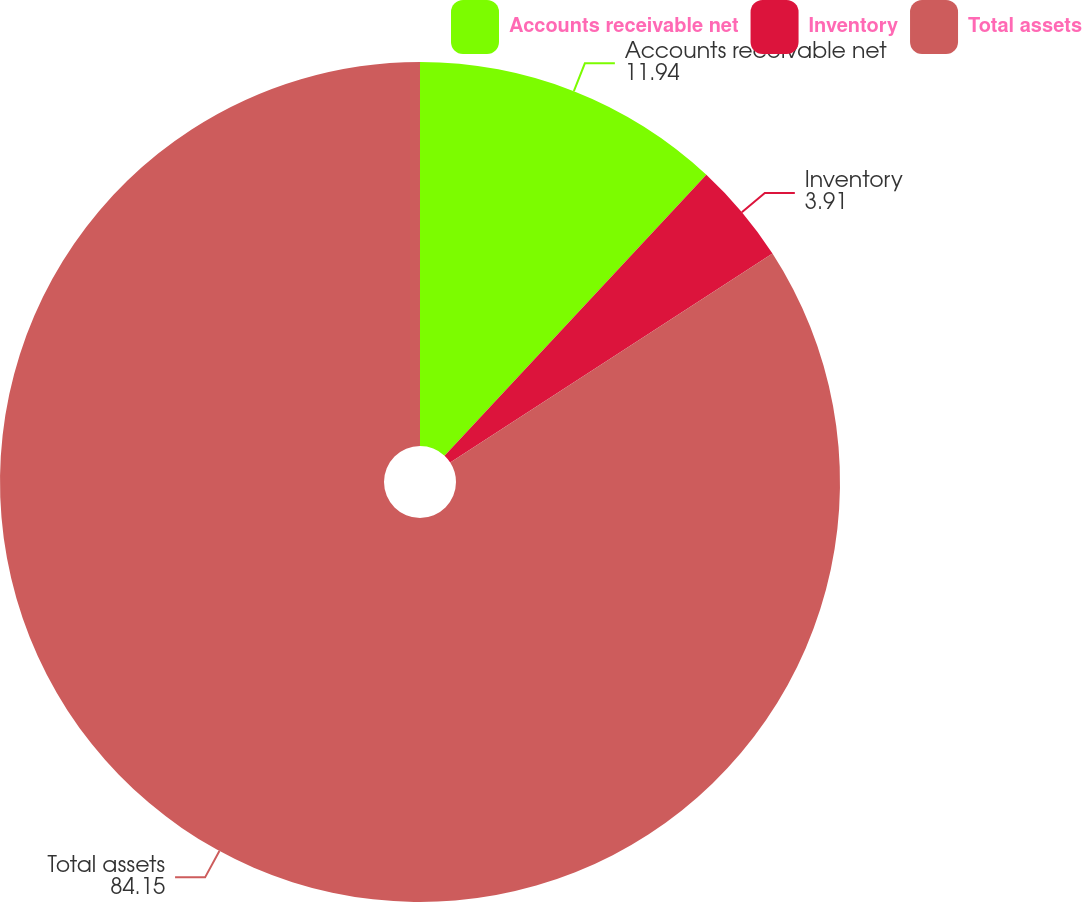<chart> <loc_0><loc_0><loc_500><loc_500><pie_chart><fcel>Accounts receivable net<fcel>Inventory<fcel>Total assets<nl><fcel>11.94%<fcel>3.91%<fcel>84.15%<nl></chart> 